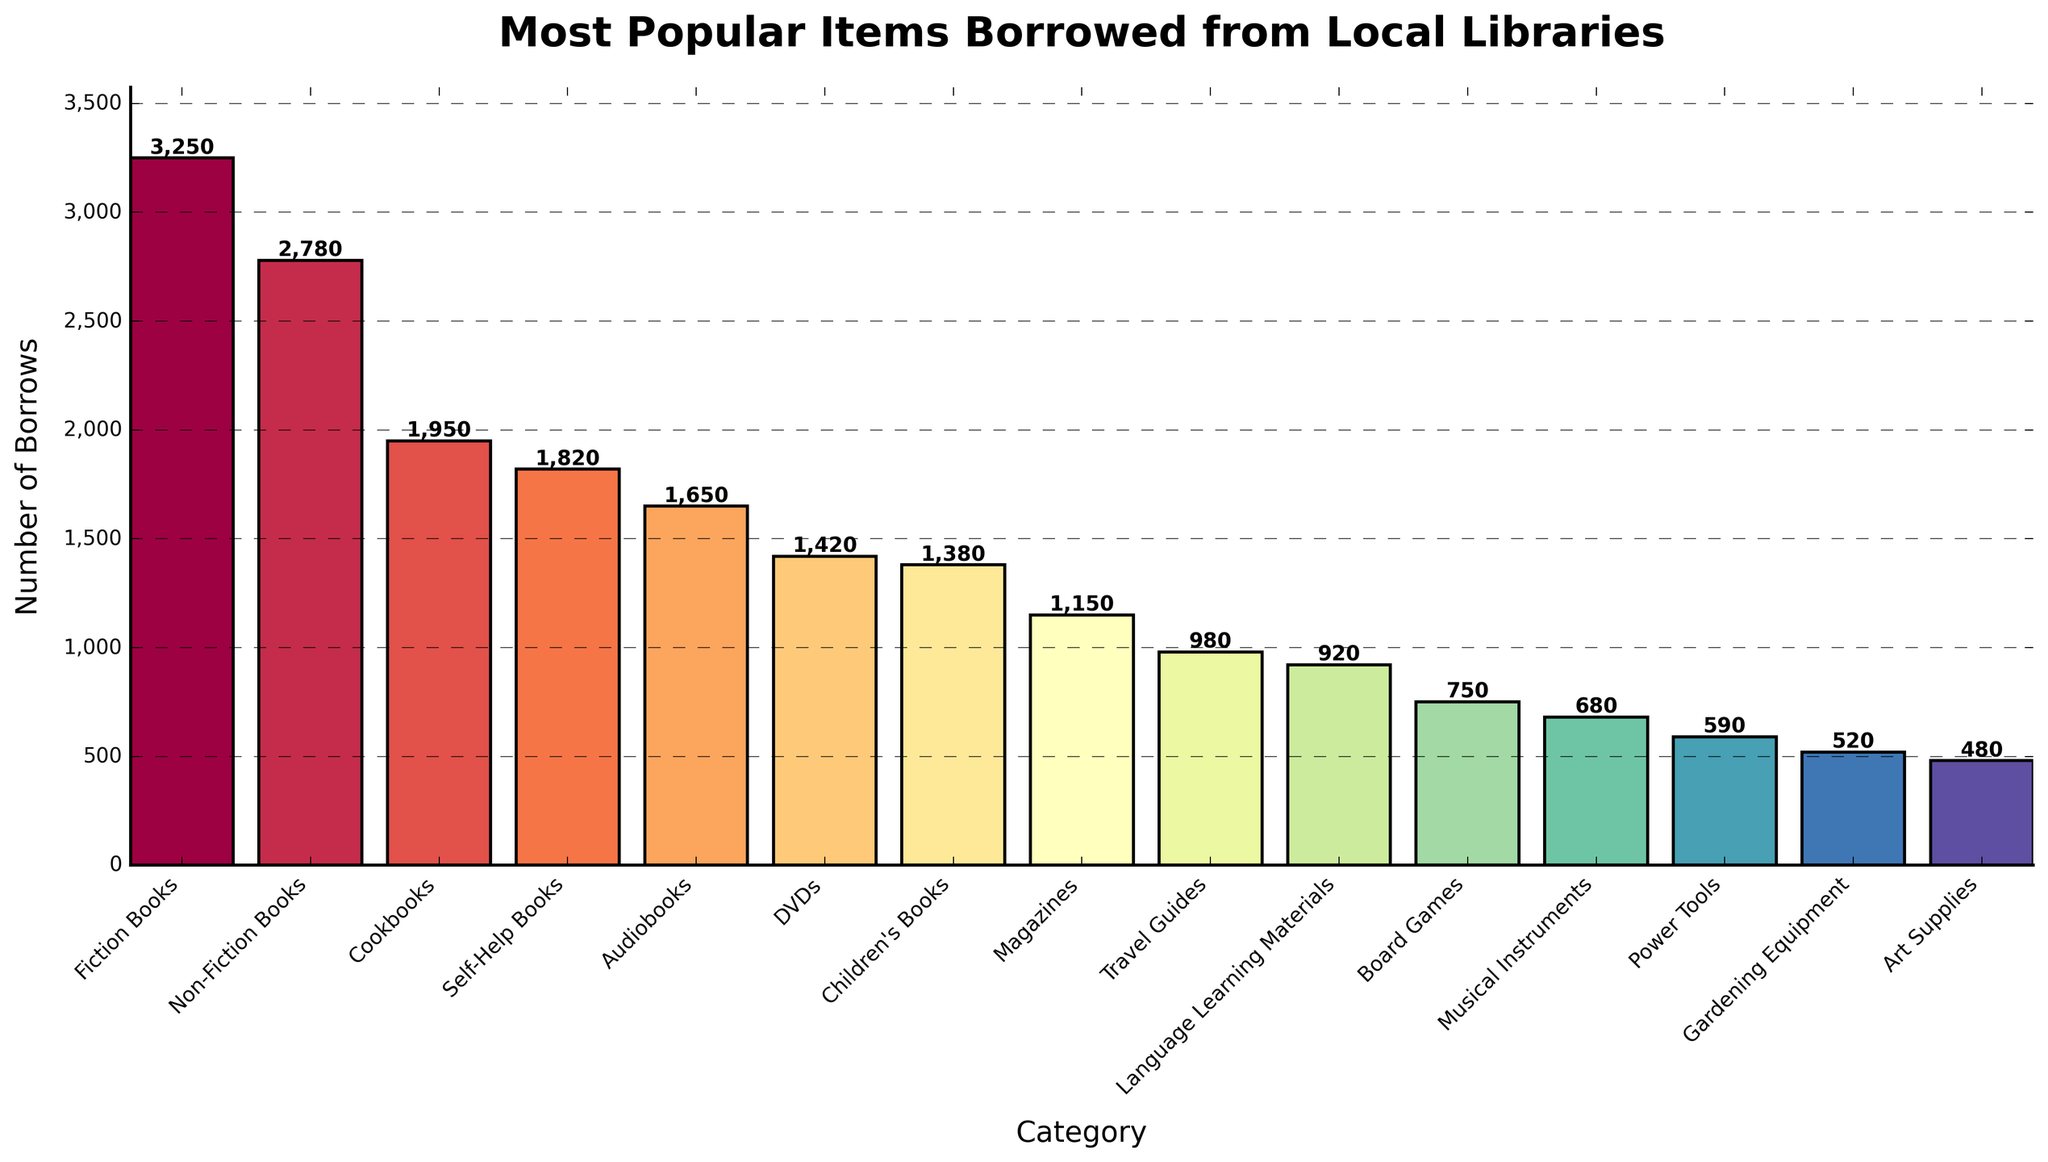Which category has the highest number of borrows? The tallest bar corresponds to the Fiction Books category with 3,250 borrows, so it has the highest number of borrows.
Answer: Fiction Books Which category has fewer borrows, DVDs or Audiobooks? By comparing the height of the bars and the labels, DVDs have 1,420 borrows while Audiobooks have 1,650 borrows. Thus, DVDs have fewer borrows.
Answer: DVDs What is the combined number of borrows for Fiction Books and Non-Fiction Books? Add the number of borrows for Fiction Books (3,250) and Non-Fiction Books (2,780): 3,250 + 2,780 = 6,030.
Answer: 6,030 Which categories have fewer than 1,000 borrows? The categories with bars that have heights less than the 1,000 mark are Travel Guides, Language Learning Materials, Board Games, Musical Instruments, Power Tools, Gardening Equipment, and Art Supplies.
Answer: Travel Guides, Language Learning Materials, Board Games, Musical Instruments, Power Tools, Gardening Equipment, Art Supplies How many more borrows do Children's Books have compared to Magazines? Subtract the number of borrows for Magazines (1,150) from Children's Books (1,380): 1,380 - 1,150 = 230.
Answer: 230 What is the average number of borrows for the top three most borrowed categories? Add the number of borrows for Fiction Books (3,250), Non-Fiction Books (2,780), and Cookbooks (1,950) and then divide by 3: (3,250 + 2,780 + 1,950) / 3 = 7,980 / 3 = 2,660
Answer: 2,660 Which category has the shortest bar in the chart? The shortest bar corresponds to the Art Supplies category with 480 borrows.
Answer: Art Supplies What is the difference in the number of borrows between Self-Help Books and Language Learning Materials? Subtract the number of borrows for Language Learning Materials (920) from Self-Help Books (1,820): 1,820 - 920 = 900.
Answer: 900 How many categories have over 1,500 borrows? The categories with bars taller than the 1,500 mark are Fiction Books, Non-Fiction Books, Cookbooks, and Self-Help Books. That's 4 categories.
Answer: 4 